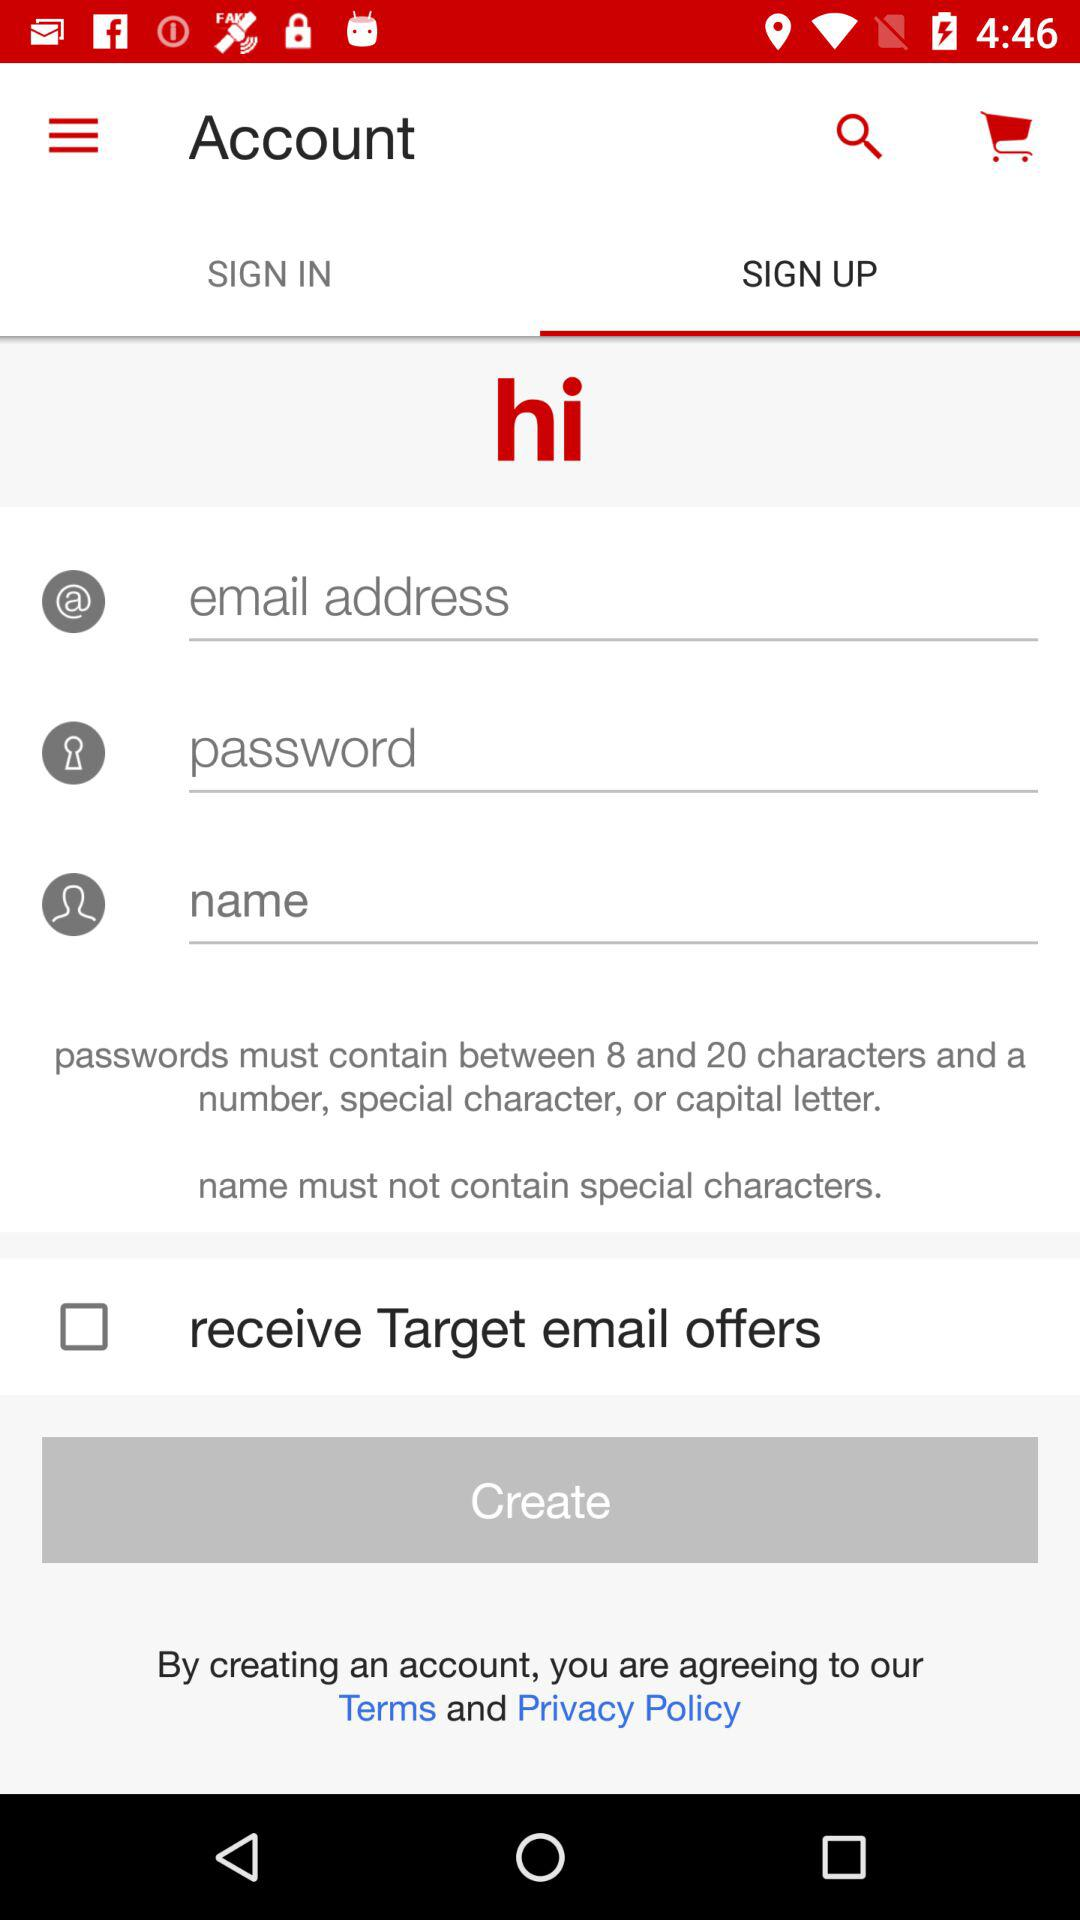Who is signing up?
When the provided information is insufficient, respond with <no answer>. <no answer> 